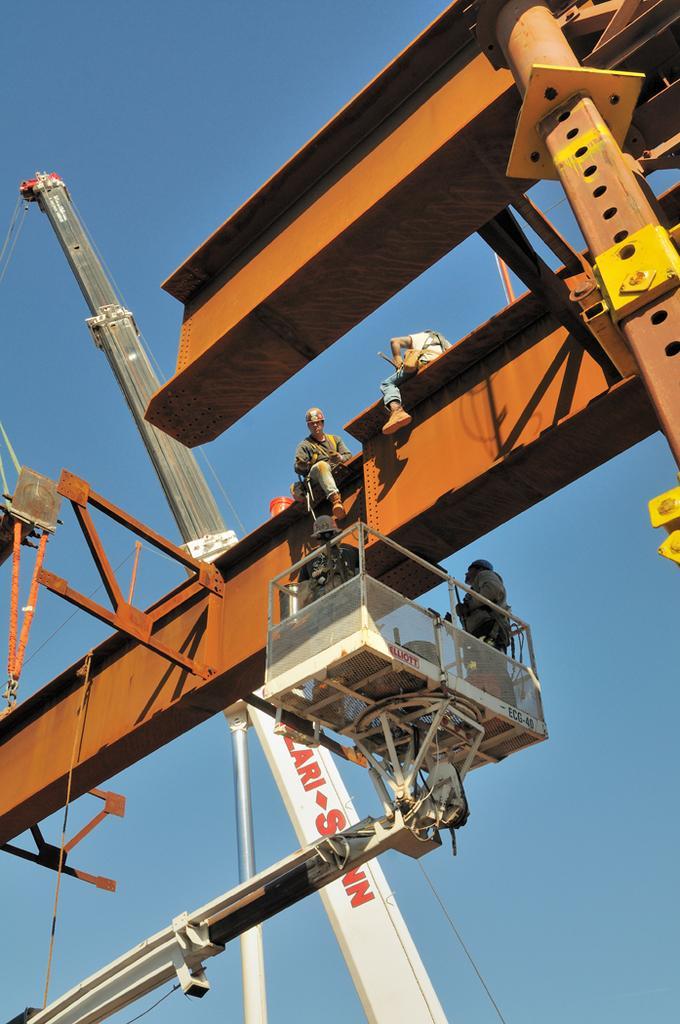How would you summarize this image in a sentence or two? In this image we can see the people. We can also see the crane, boom lifts and also the metal object. In the background we can see the sky. 